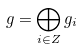<formula> <loc_0><loc_0><loc_500><loc_500>g = \bigoplus _ { i \in Z } g _ { i }</formula> 